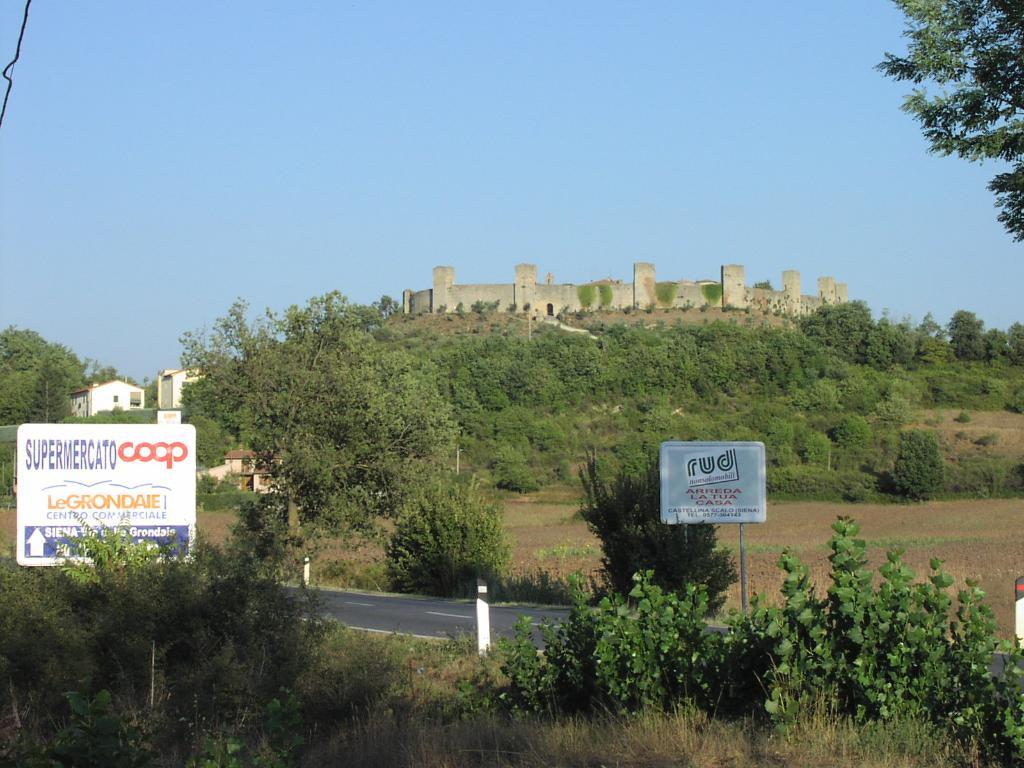What type of natural elements can be seen in the image? There are trees and plants in the image. What man-made structures are visible in the image? There are boards and buildings in the image. What is the position of the sense of flight in the image? There is no sense of flight present in the image. How does the position of the sense of flight affect the trees in the image? Since there is no sense of flight in the image, it does not affect the trees. 